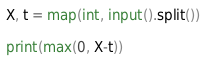Convert code to text. <code><loc_0><loc_0><loc_500><loc_500><_Python_>X, t = map(int, input().split())

print(max(0, X-t))</code> 